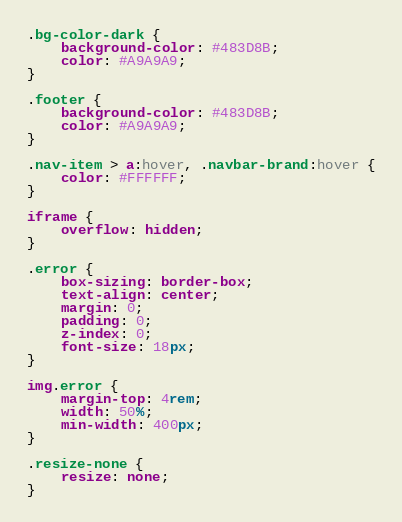Convert code to text. <code><loc_0><loc_0><loc_500><loc_500><_CSS_>.bg-color-dark {
    background-color: #483D8B;
    color: #A9A9A9;
}

.footer {
    background-color: #483D8B;
    color: #A9A9A9;
}

.nav-item > a:hover, .navbar-brand:hover {
    color: #FFFFFF;
}

iframe {
    overflow: hidden;
}

.error {
    box-sizing: border-box;
    text-align: center;
    margin: 0;
    padding: 0;
    z-index: 0;
    font-size: 18px;
}

img.error {
    margin-top: 4rem;
    width: 50%;
    min-width: 400px;
}

.resize-none {
    resize: none;
}</code> 